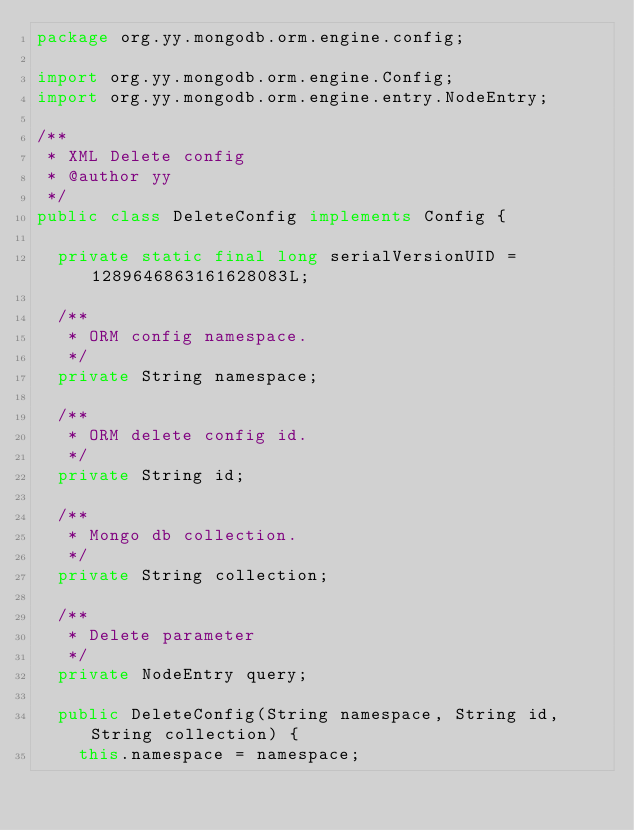Convert code to text. <code><loc_0><loc_0><loc_500><loc_500><_Java_>package org.yy.mongodb.orm.engine.config;

import org.yy.mongodb.orm.engine.Config;
import org.yy.mongodb.orm.engine.entry.NodeEntry;

/**
 * XML Delete config
 * @author yy
 */
public class DeleteConfig implements Config {

  private static final long serialVersionUID = 1289646863161628083L;

  /**
   * ORM config namespace.
   */
  private String namespace;
  
  /**
   * ORM delete config id.
   */
  private String id;

  /**
   * Mongo db collection.
   */
  private String collection;

  /**
   * Delete parameter
   */
  private NodeEntry query;

  public DeleteConfig(String namespace, String id, String collection) {
    this.namespace = namespace;</code> 